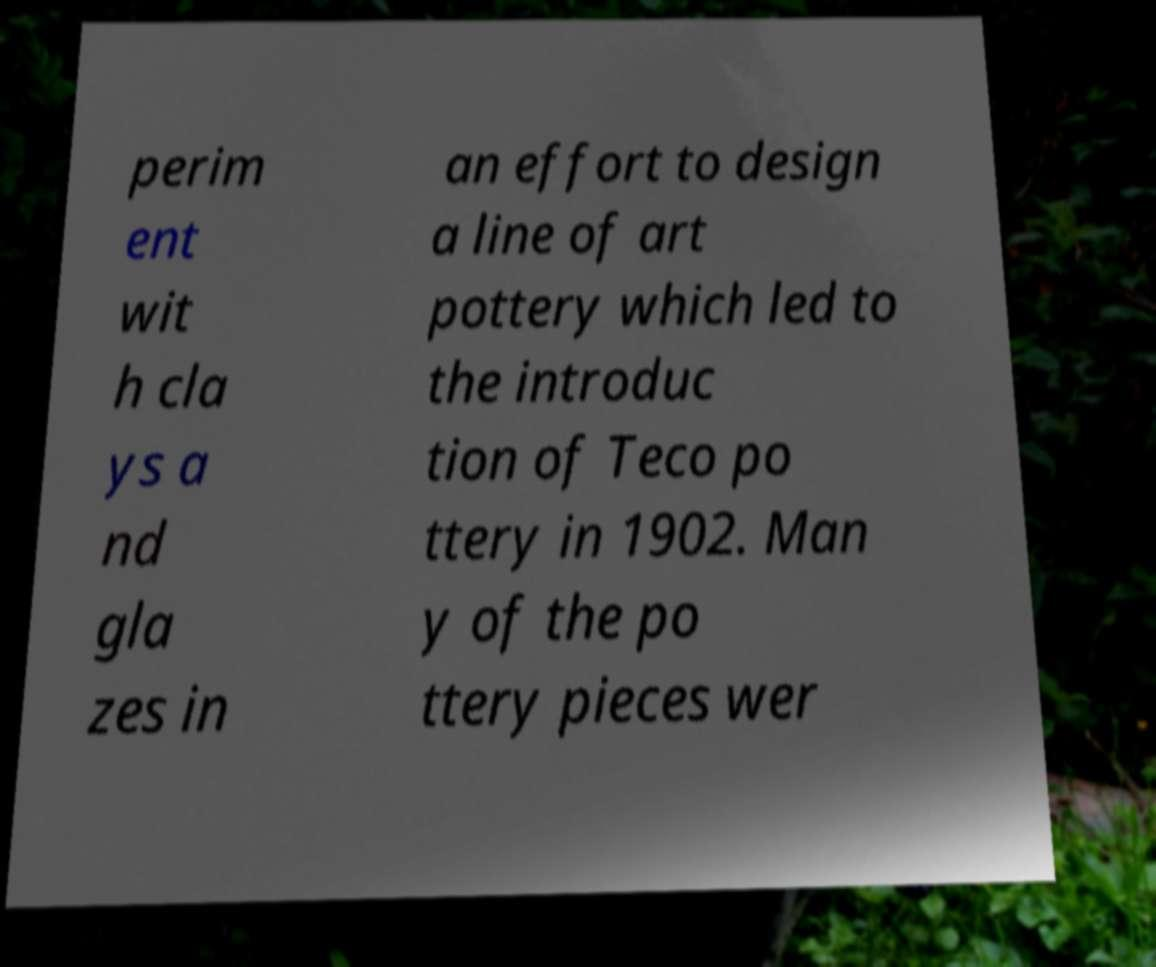Can you accurately transcribe the text from the provided image for me? perim ent wit h cla ys a nd gla zes in an effort to design a line of art pottery which led to the introduc tion of Teco po ttery in 1902. Man y of the po ttery pieces wer 